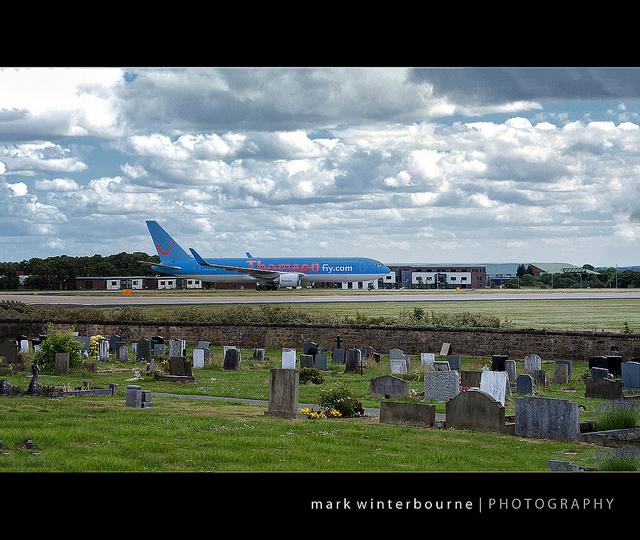Are there clouds?
Answer briefly. Yes. What is in the foreground of this picture?
Quick response, please. Cemetery. What type of plane is on the runway?
Concise answer only. Commercial. 